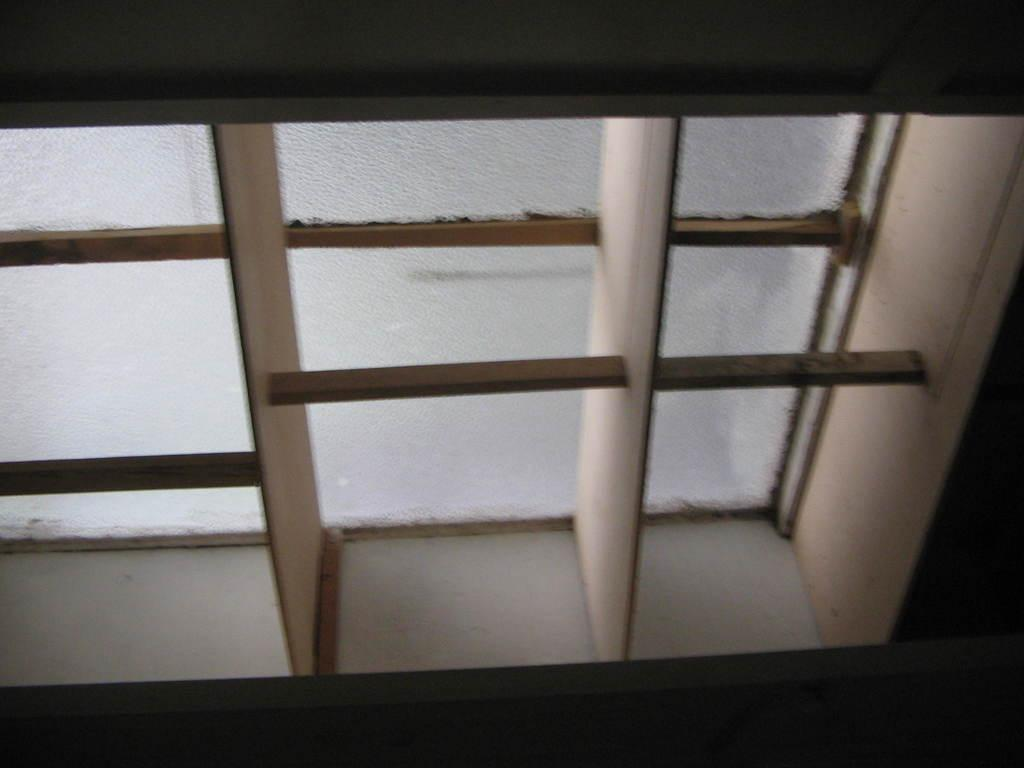What type of window is visible in the image? There is a glass window in the image. Are there any additional features on the glass window? Yes, the glass window has iron grilles. What type of attention does the box receive from the sponge in the image? There is no box or sponge present in the image, so this question cannot be answered. 